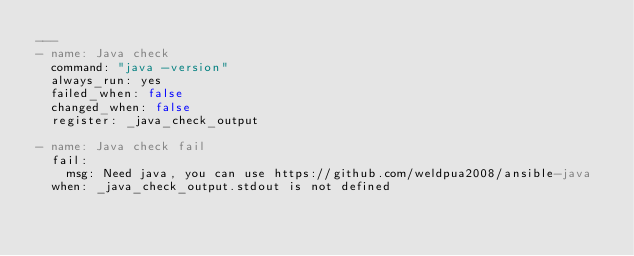<code> <loc_0><loc_0><loc_500><loc_500><_YAML_>---
- name: Java check
  command: "java -version"
  always_run: yes
  failed_when: false
  changed_when: false
  register: _java_check_output

- name: Java check fail
  fail:
    msg: Need java, you can use https://github.com/weldpua2008/ansible-java
  when: _java_check_output.stdout is not defined</code> 